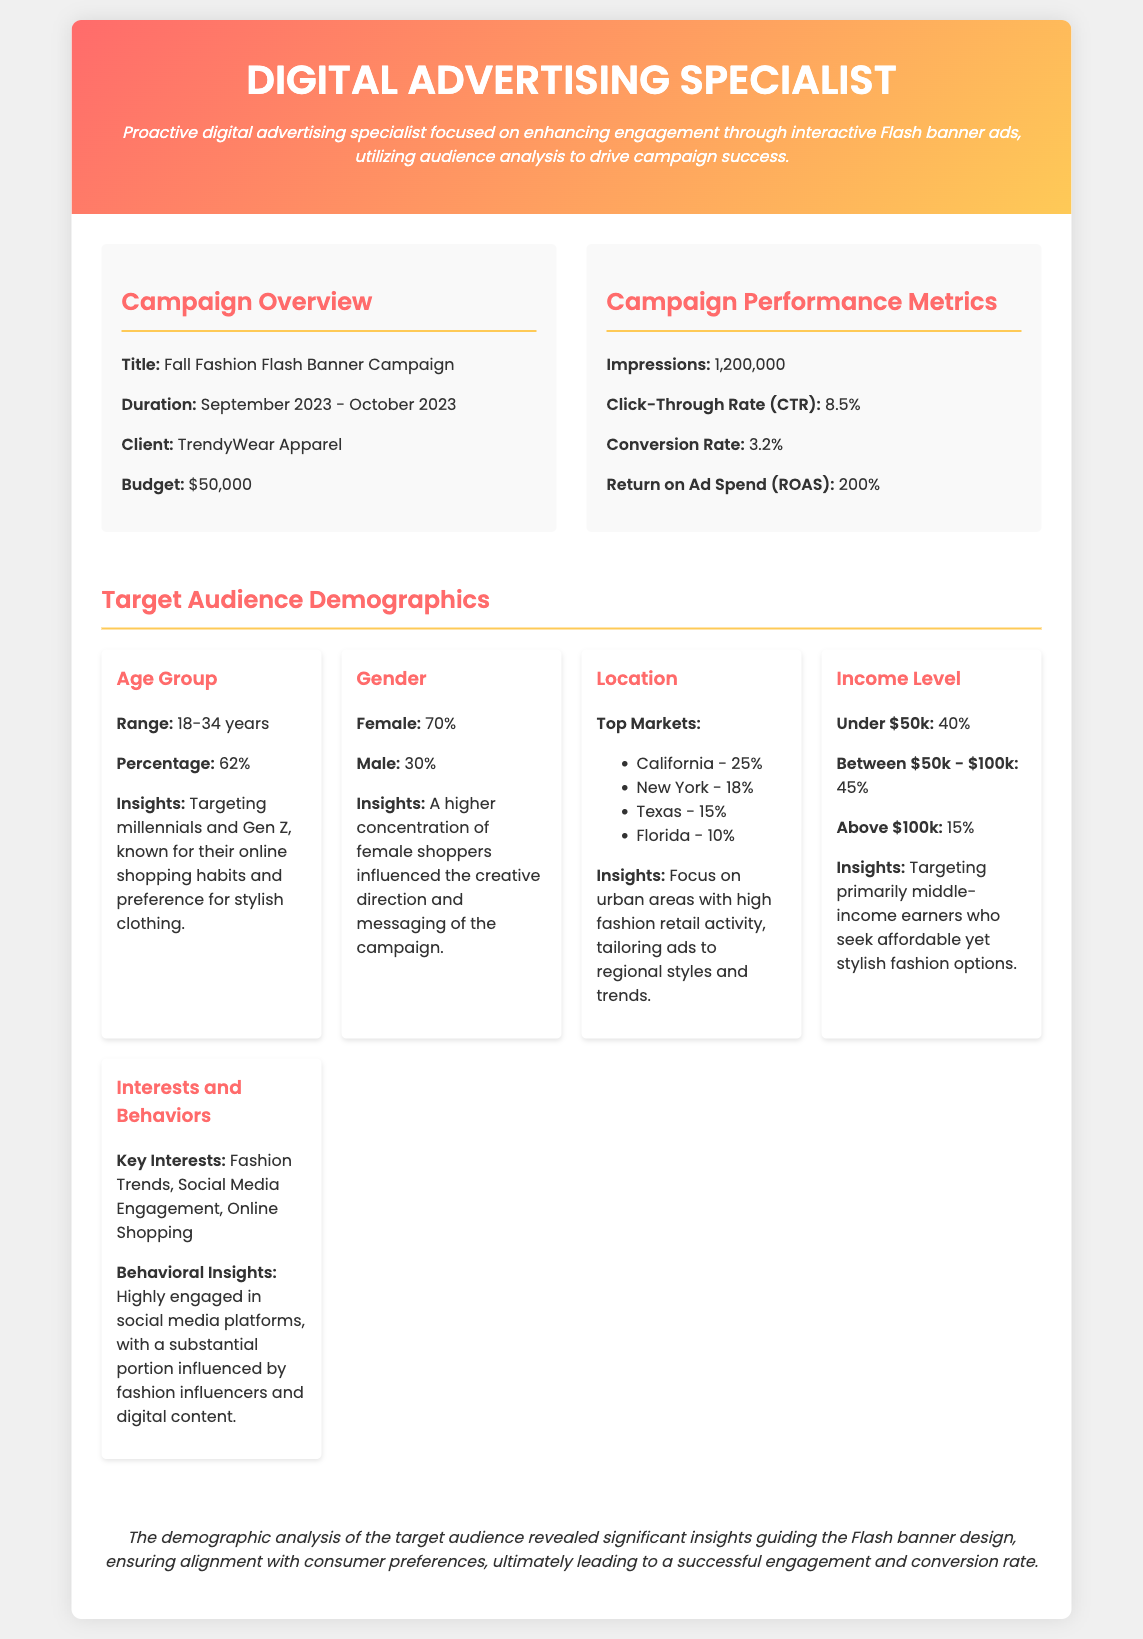What is the title of the campaign? The title of the campaign is specified in the campaign overview section.
Answer: Fall Fashion Flash Banner Campaign What is the duration of the campaign? The duration is mentioned explicitly in the campaign overview.
Answer: September 2023 - October 2023 What was the budget for the campaign? The budget can be found in the campaign overview.
Answer: $50,000 What is the Click-Through Rate (CTR)? The CTR is listed in the performance metrics section of the document.
Answer: 8.5% What percentage of the target audience is aged 18-34 years? The age group percentage is specified in the demographics section.
Answer: 62% Which gender had a higher concentration in the campaign? The gender ratios are given in the demographics section.
Answer: Female What are the top three markets by percentage for the target audience? The top markets with their percentages are listed in the demographics section.
Answer: California, New York, Texas What percentage of the audience falls under the income level of $50k? The income level distribution is specified in the demographics.
Answer: 40% What insights were provided for interests and behaviors? Insights on the interests and behaviors are detailed in the demographics section.
Answer: Highly engaged in social media platforms 